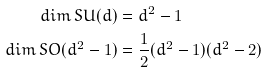Convert formula to latex. <formula><loc_0><loc_0><loc_500><loc_500>d i m \, S U ( d ) & = d ^ { 2 } - 1 \\ d i m \, S O ( d ^ { 2 } - 1 ) & = \frac { 1 } { 2 } ( d ^ { 2 } - 1 ) ( d ^ { 2 } - 2 ) \\</formula> 